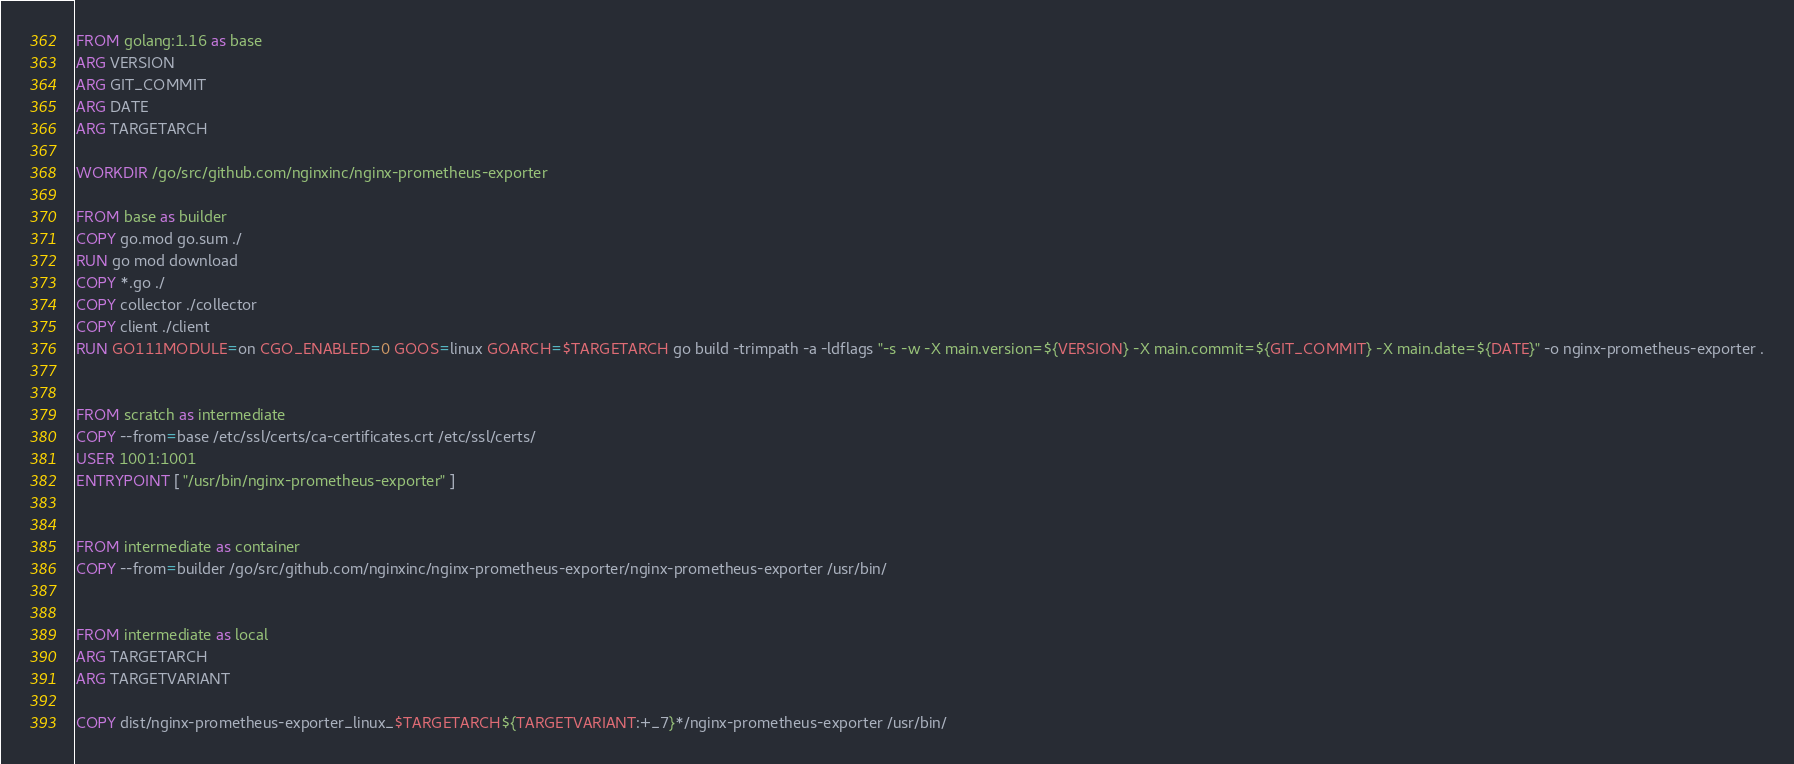<code> <loc_0><loc_0><loc_500><loc_500><_Dockerfile_>FROM golang:1.16 as base
ARG VERSION
ARG GIT_COMMIT
ARG DATE
ARG TARGETARCH

WORKDIR /go/src/github.com/nginxinc/nginx-prometheus-exporter

FROM base as builder
COPY go.mod go.sum ./
RUN go mod download
COPY *.go ./
COPY collector ./collector
COPY client ./client
RUN GO111MODULE=on CGO_ENABLED=0 GOOS=linux GOARCH=$TARGETARCH go build -trimpath -a -ldflags "-s -w -X main.version=${VERSION} -X main.commit=${GIT_COMMIT} -X main.date=${DATE}" -o nginx-prometheus-exporter .


FROM scratch as intermediate
COPY --from=base /etc/ssl/certs/ca-certificates.crt /etc/ssl/certs/
USER 1001:1001
ENTRYPOINT [ "/usr/bin/nginx-prometheus-exporter" ]


FROM intermediate as container
COPY --from=builder /go/src/github.com/nginxinc/nginx-prometheus-exporter/nginx-prometheus-exporter /usr/bin/


FROM intermediate as local
ARG TARGETARCH
ARG TARGETVARIANT

COPY dist/nginx-prometheus-exporter_linux_$TARGETARCH${TARGETVARIANT:+_7}*/nginx-prometheus-exporter /usr/bin/
</code> 